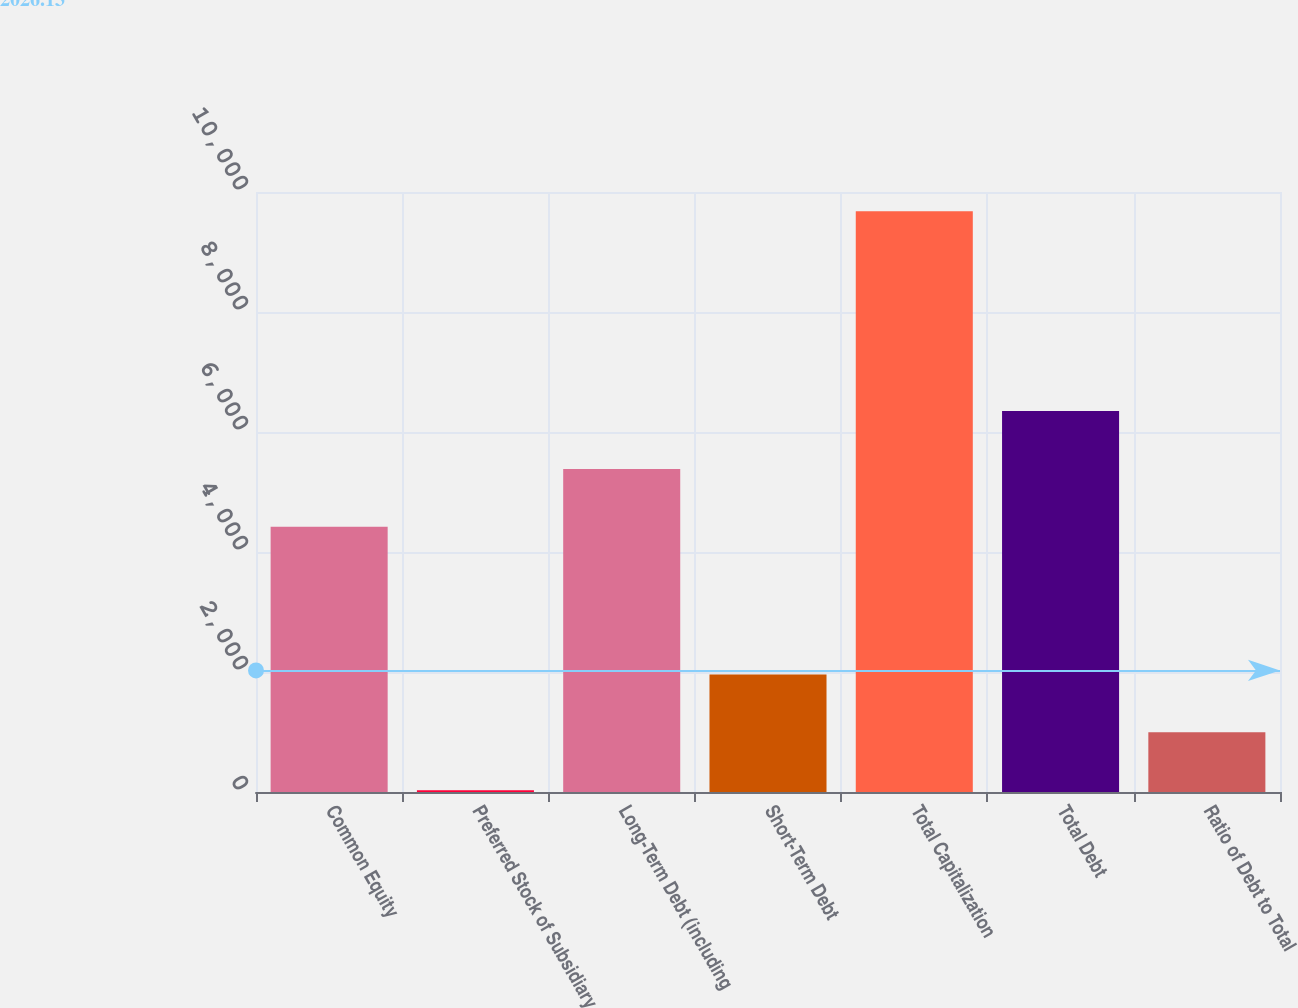Convert chart to OTSL. <chart><loc_0><loc_0><loc_500><loc_500><bar_chart><fcel>Common Equity<fcel>Preferred Stock of Subsidiary<fcel>Long-Term Debt (including<fcel>Short-Term Debt<fcel>Total Capitalization<fcel>Total Debt<fcel>Ratio of Debt to Total<nl><fcel>4419.7<fcel>30.4<fcel>5384.48<fcel>1959.96<fcel>9678.2<fcel>6349.26<fcel>995.18<nl></chart> 